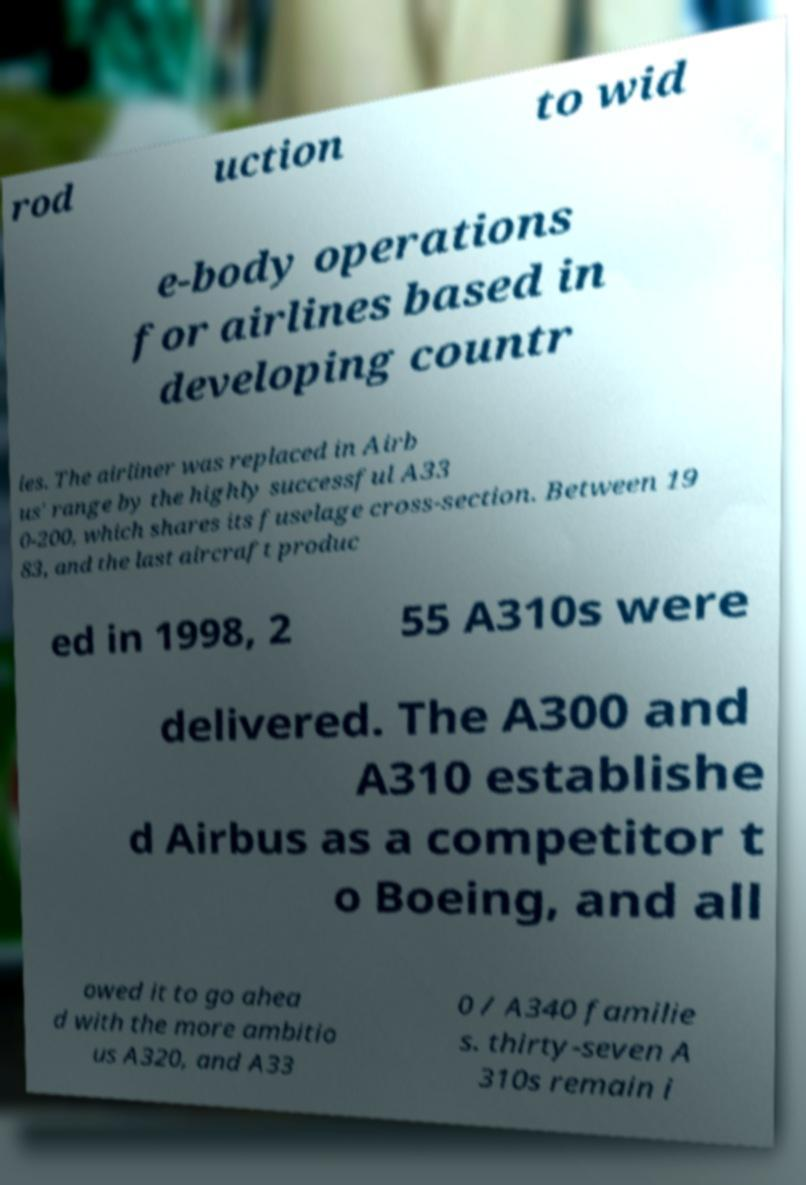There's text embedded in this image that I need extracted. Can you transcribe it verbatim? rod uction to wid e-body operations for airlines based in developing countr ies. The airliner was replaced in Airb us' range by the highly successful A33 0-200, which shares its fuselage cross-section. Between 19 83, and the last aircraft produc ed in 1998, 2 55 A310s were delivered. The A300 and A310 establishe d Airbus as a competitor t o Boeing, and all owed it to go ahea d with the more ambitio us A320, and A33 0 / A340 familie s. thirty-seven A 310s remain i 